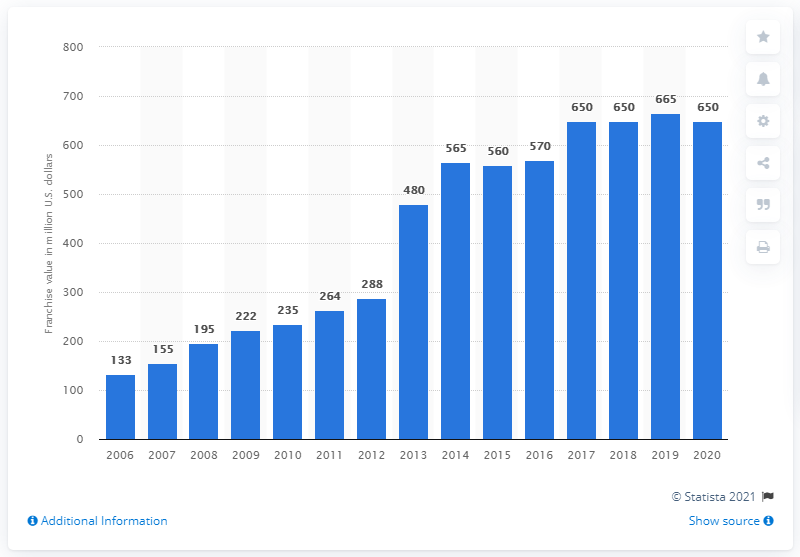Specify some key components in this picture. The value of the Pittsburgh Penguins in dollars in 2020 was estimated to be approximately 650 million dollars. 